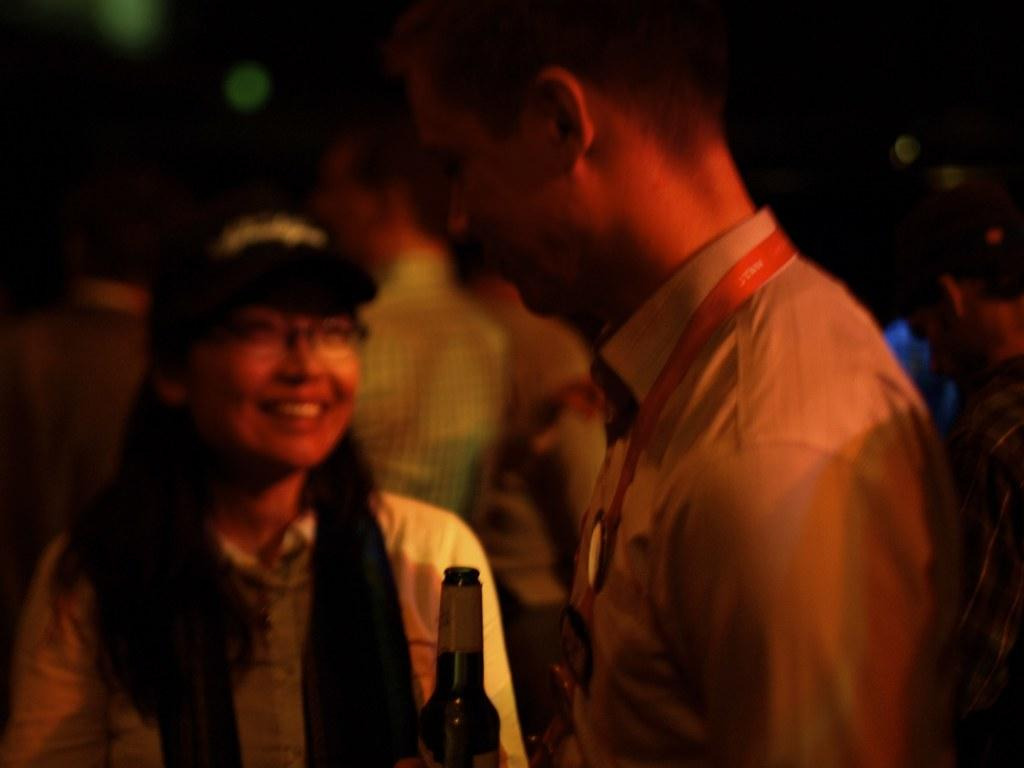How many people are in the center of the image? There are two persons standing in the center of the image. What is the facial expression of the woman in the image? The woman is smiling. What is the man holding in the image? The man is holding a beer bottle. Can you describe the people in the background of the image? There are additional people standing in the background of the image. What type of loaf is being served on the table in the image? There is no table or loaf present in the image; it features two people standing in the center, with a man holding a beer bottle and a smiling woman. 